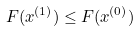Convert formula to latex. <formula><loc_0><loc_0><loc_500><loc_500>F ( x ^ { ( 1 ) } ) \leq F ( x ^ { ( 0 ) } )</formula> 